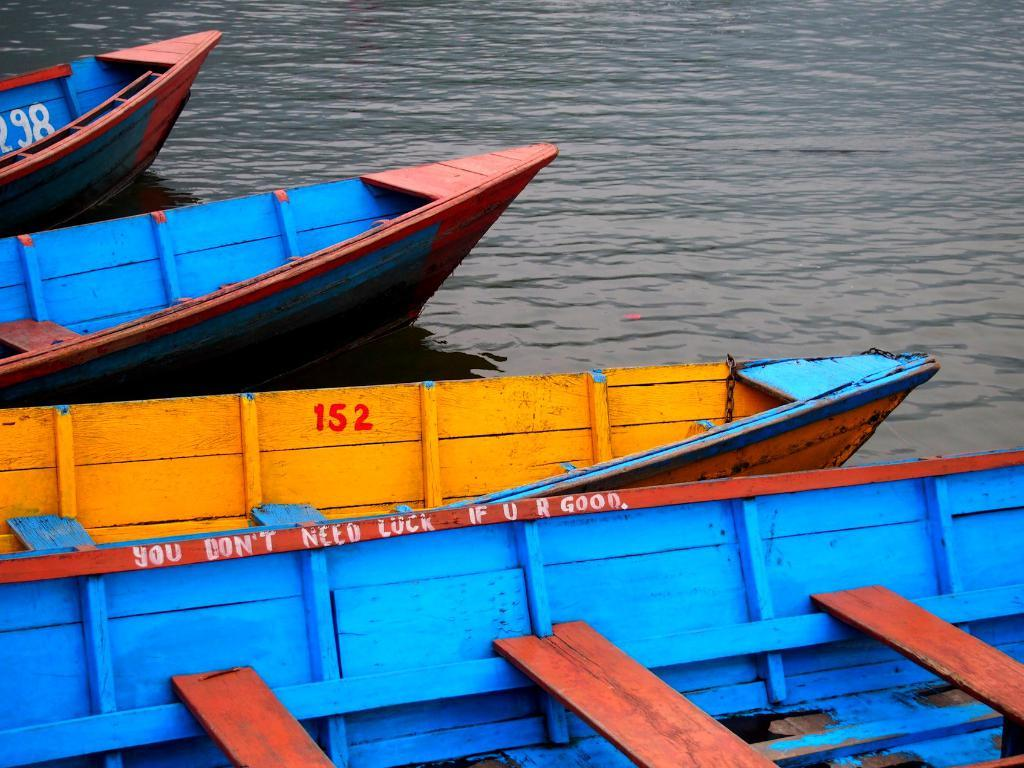How many boats are visible in the image? There are four boats in the image. Where are the boats located? The boats are on the water. What type of design can be seen on the boats during the recess? There is no mention of a design on the boats, nor is there any reference to a recess in the image. 